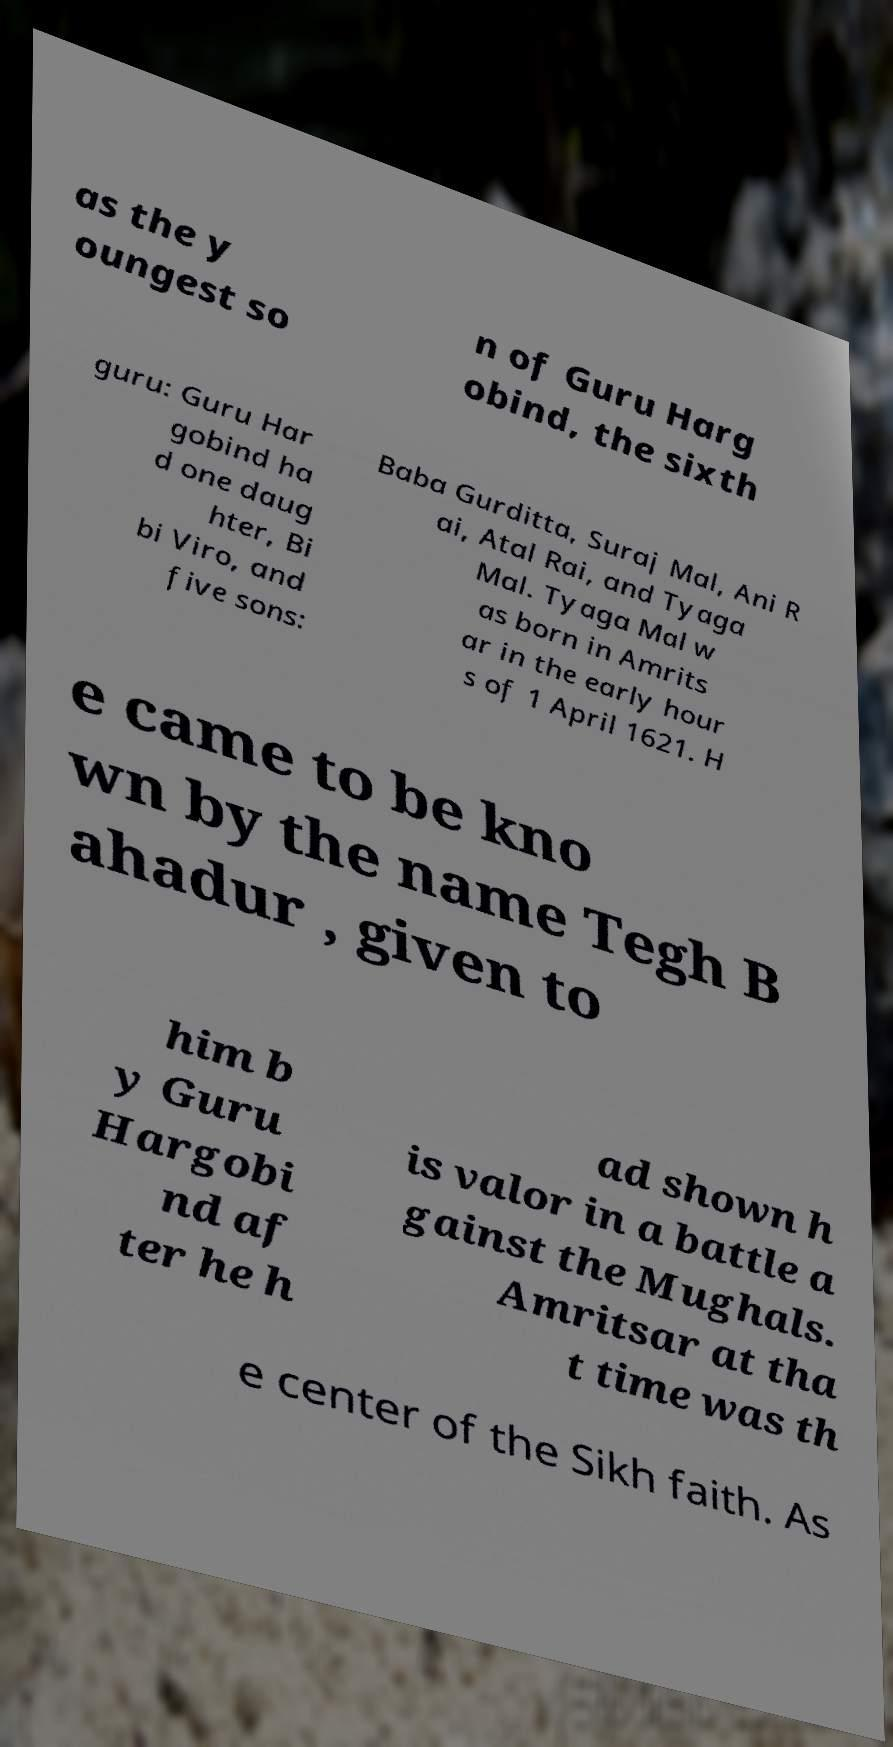For documentation purposes, I need the text within this image transcribed. Could you provide that? as the y oungest so n of Guru Harg obind, the sixth guru: Guru Har gobind ha d one daug hter, Bi bi Viro, and five sons: Baba Gurditta, Suraj Mal, Ani R ai, Atal Rai, and Tyaga Mal. Tyaga Mal w as born in Amrits ar in the early hour s of 1 April 1621. H e came to be kno wn by the name Tegh B ahadur , given to him b y Guru Hargobi nd af ter he h ad shown h is valor in a battle a gainst the Mughals. Amritsar at tha t time was th e center of the Sikh faith. As 